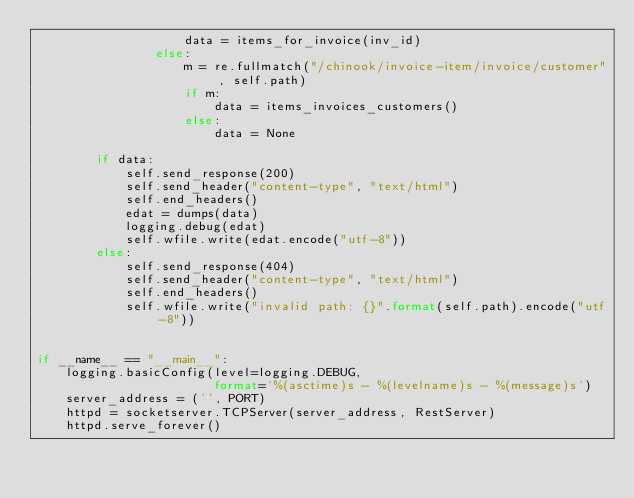Convert code to text. <code><loc_0><loc_0><loc_500><loc_500><_Python_>                    data = items_for_invoice(inv_id)
                else:
                    m = re.fullmatch("/chinook/invoice-item/invoice/customer", self.path)
                    if m:
                        data = items_invoices_customers()
                    else:
                        data = None

        if data:
            self.send_response(200)
            self.send_header("content-type", "text/html")
            self.end_headers()
            edat = dumps(data)
            logging.debug(edat)
            self.wfile.write(edat.encode("utf-8"))
        else:
            self.send_response(404)
            self.send_header("content-type", "text/html")
            self.end_headers()
            self.wfile.write("invalid path: {}".format(self.path).encode("utf-8"))


if __name__ == "__main__":
    logging.basicConfig(level=logging.DEBUG,
                        format='%(asctime)s - %(levelname)s - %(message)s')
    server_address = ('', PORT)
    httpd = socketserver.TCPServer(server_address, RestServer)
    httpd.serve_forever()



</code> 